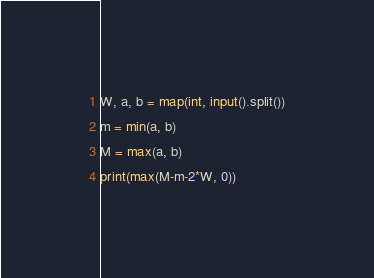Convert code to text. <code><loc_0><loc_0><loc_500><loc_500><_Python_>W, a, b = map(int, input().split())
m = min(a, b)
M = max(a, b)
print(max(M-m-2*W, 0))</code> 